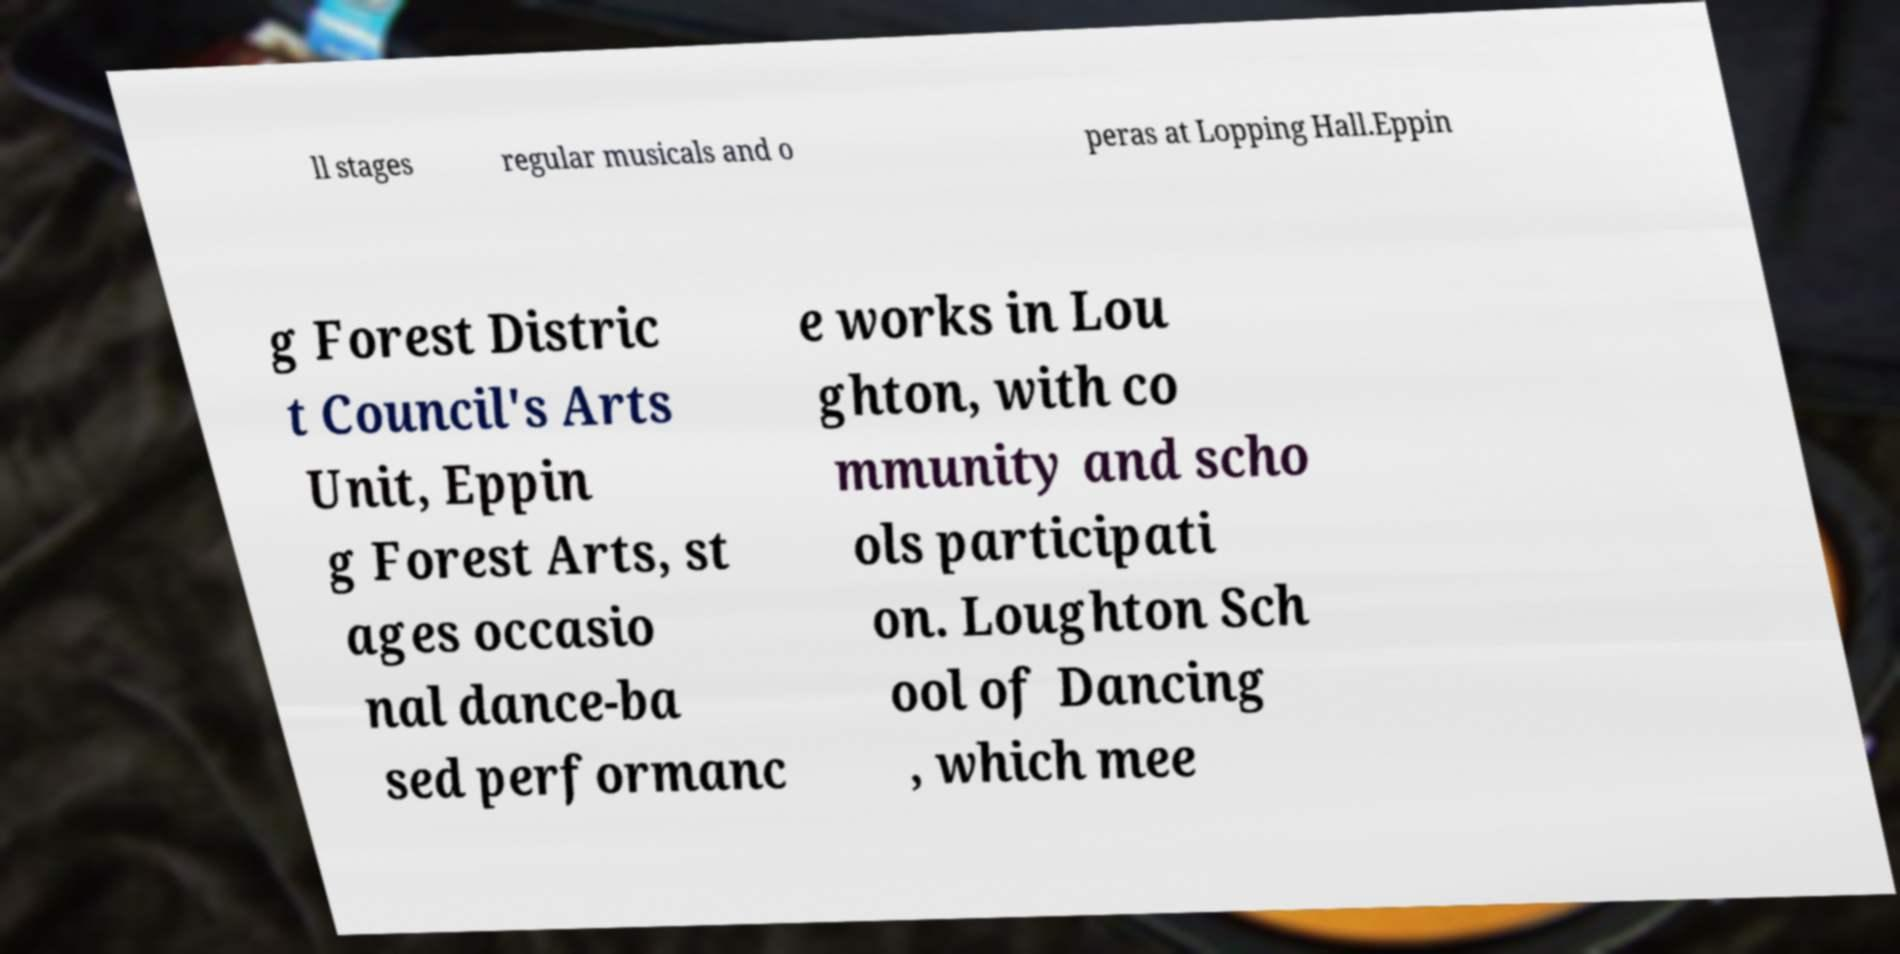I need the written content from this picture converted into text. Can you do that? ll stages regular musicals and o peras at Lopping Hall.Eppin g Forest Distric t Council's Arts Unit, Eppin g Forest Arts, st ages occasio nal dance-ba sed performanc e works in Lou ghton, with co mmunity and scho ols participati on. Loughton Sch ool of Dancing , which mee 